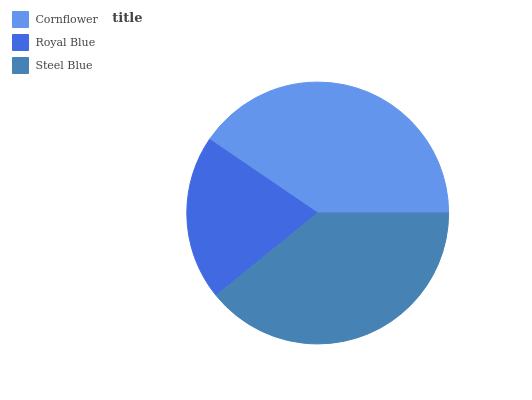Is Royal Blue the minimum?
Answer yes or no. Yes. Is Cornflower the maximum?
Answer yes or no. Yes. Is Steel Blue the minimum?
Answer yes or no. No. Is Steel Blue the maximum?
Answer yes or no. No. Is Steel Blue greater than Royal Blue?
Answer yes or no. Yes. Is Royal Blue less than Steel Blue?
Answer yes or no. Yes. Is Royal Blue greater than Steel Blue?
Answer yes or no. No. Is Steel Blue less than Royal Blue?
Answer yes or no. No. Is Steel Blue the high median?
Answer yes or no. Yes. Is Steel Blue the low median?
Answer yes or no. Yes. Is Cornflower the high median?
Answer yes or no. No. Is Cornflower the low median?
Answer yes or no. No. 